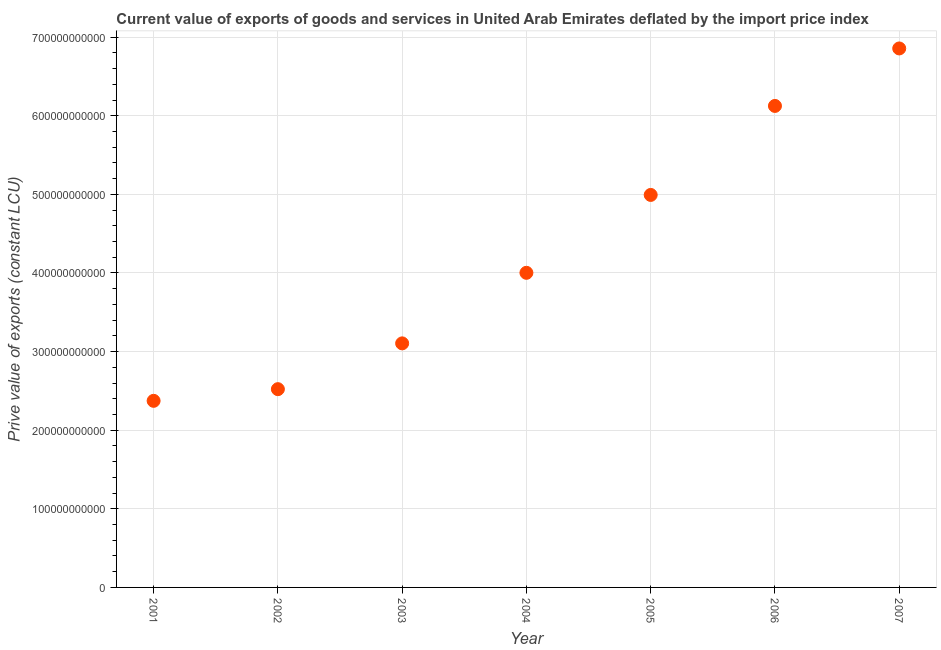What is the price value of exports in 2001?
Give a very brief answer. 2.37e+11. Across all years, what is the maximum price value of exports?
Offer a very short reply. 6.86e+11. Across all years, what is the minimum price value of exports?
Offer a terse response. 2.37e+11. What is the sum of the price value of exports?
Your answer should be compact. 3.00e+12. What is the difference between the price value of exports in 2002 and 2004?
Make the answer very short. -1.48e+11. What is the average price value of exports per year?
Give a very brief answer. 4.28e+11. What is the median price value of exports?
Offer a terse response. 4.00e+11. In how many years, is the price value of exports greater than 620000000000 LCU?
Your response must be concise. 1. Do a majority of the years between 2005 and 2006 (inclusive) have price value of exports greater than 340000000000 LCU?
Your response must be concise. Yes. What is the ratio of the price value of exports in 2004 to that in 2006?
Offer a terse response. 0.65. What is the difference between the highest and the second highest price value of exports?
Provide a succinct answer. 7.31e+1. Is the sum of the price value of exports in 2006 and 2007 greater than the maximum price value of exports across all years?
Offer a very short reply. Yes. What is the difference between the highest and the lowest price value of exports?
Keep it short and to the point. 4.48e+11. Does the price value of exports monotonically increase over the years?
Keep it short and to the point. Yes. How many dotlines are there?
Give a very brief answer. 1. What is the difference between two consecutive major ticks on the Y-axis?
Offer a very short reply. 1.00e+11. What is the title of the graph?
Give a very brief answer. Current value of exports of goods and services in United Arab Emirates deflated by the import price index. What is the label or title of the X-axis?
Give a very brief answer. Year. What is the label or title of the Y-axis?
Offer a terse response. Prive value of exports (constant LCU). What is the Prive value of exports (constant LCU) in 2001?
Make the answer very short. 2.37e+11. What is the Prive value of exports (constant LCU) in 2002?
Your answer should be compact. 2.52e+11. What is the Prive value of exports (constant LCU) in 2003?
Keep it short and to the point. 3.10e+11. What is the Prive value of exports (constant LCU) in 2004?
Your response must be concise. 4.00e+11. What is the Prive value of exports (constant LCU) in 2005?
Keep it short and to the point. 4.99e+11. What is the Prive value of exports (constant LCU) in 2006?
Keep it short and to the point. 6.12e+11. What is the Prive value of exports (constant LCU) in 2007?
Keep it short and to the point. 6.86e+11. What is the difference between the Prive value of exports (constant LCU) in 2001 and 2002?
Make the answer very short. -1.48e+1. What is the difference between the Prive value of exports (constant LCU) in 2001 and 2003?
Ensure brevity in your answer.  -7.31e+1. What is the difference between the Prive value of exports (constant LCU) in 2001 and 2004?
Give a very brief answer. -1.63e+11. What is the difference between the Prive value of exports (constant LCU) in 2001 and 2005?
Your answer should be compact. -2.62e+11. What is the difference between the Prive value of exports (constant LCU) in 2001 and 2006?
Provide a succinct answer. -3.75e+11. What is the difference between the Prive value of exports (constant LCU) in 2001 and 2007?
Offer a terse response. -4.48e+11. What is the difference between the Prive value of exports (constant LCU) in 2002 and 2003?
Make the answer very short. -5.82e+1. What is the difference between the Prive value of exports (constant LCU) in 2002 and 2004?
Your response must be concise. -1.48e+11. What is the difference between the Prive value of exports (constant LCU) in 2002 and 2005?
Your answer should be very brief. -2.47e+11. What is the difference between the Prive value of exports (constant LCU) in 2002 and 2006?
Provide a succinct answer. -3.60e+11. What is the difference between the Prive value of exports (constant LCU) in 2002 and 2007?
Your answer should be compact. -4.33e+11. What is the difference between the Prive value of exports (constant LCU) in 2003 and 2004?
Your answer should be compact. -8.98e+1. What is the difference between the Prive value of exports (constant LCU) in 2003 and 2005?
Offer a very short reply. -1.89e+11. What is the difference between the Prive value of exports (constant LCU) in 2003 and 2006?
Offer a very short reply. -3.02e+11. What is the difference between the Prive value of exports (constant LCU) in 2003 and 2007?
Ensure brevity in your answer.  -3.75e+11. What is the difference between the Prive value of exports (constant LCU) in 2004 and 2005?
Keep it short and to the point. -9.91e+1. What is the difference between the Prive value of exports (constant LCU) in 2004 and 2006?
Offer a very short reply. -2.12e+11. What is the difference between the Prive value of exports (constant LCU) in 2004 and 2007?
Offer a very short reply. -2.85e+11. What is the difference between the Prive value of exports (constant LCU) in 2005 and 2006?
Offer a terse response. -1.13e+11. What is the difference between the Prive value of exports (constant LCU) in 2005 and 2007?
Offer a very short reply. -1.86e+11. What is the difference between the Prive value of exports (constant LCU) in 2006 and 2007?
Ensure brevity in your answer.  -7.31e+1. What is the ratio of the Prive value of exports (constant LCU) in 2001 to that in 2002?
Your answer should be compact. 0.94. What is the ratio of the Prive value of exports (constant LCU) in 2001 to that in 2003?
Offer a terse response. 0.77. What is the ratio of the Prive value of exports (constant LCU) in 2001 to that in 2004?
Provide a short and direct response. 0.59. What is the ratio of the Prive value of exports (constant LCU) in 2001 to that in 2005?
Your answer should be compact. 0.47. What is the ratio of the Prive value of exports (constant LCU) in 2001 to that in 2006?
Your answer should be very brief. 0.39. What is the ratio of the Prive value of exports (constant LCU) in 2001 to that in 2007?
Keep it short and to the point. 0.35. What is the ratio of the Prive value of exports (constant LCU) in 2002 to that in 2003?
Your response must be concise. 0.81. What is the ratio of the Prive value of exports (constant LCU) in 2002 to that in 2004?
Your answer should be very brief. 0.63. What is the ratio of the Prive value of exports (constant LCU) in 2002 to that in 2005?
Make the answer very short. 0.51. What is the ratio of the Prive value of exports (constant LCU) in 2002 to that in 2006?
Offer a very short reply. 0.41. What is the ratio of the Prive value of exports (constant LCU) in 2002 to that in 2007?
Your response must be concise. 0.37. What is the ratio of the Prive value of exports (constant LCU) in 2003 to that in 2004?
Your answer should be compact. 0.78. What is the ratio of the Prive value of exports (constant LCU) in 2003 to that in 2005?
Ensure brevity in your answer.  0.62. What is the ratio of the Prive value of exports (constant LCU) in 2003 to that in 2006?
Make the answer very short. 0.51. What is the ratio of the Prive value of exports (constant LCU) in 2003 to that in 2007?
Provide a succinct answer. 0.45. What is the ratio of the Prive value of exports (constant LCU) in 2004 to that in 2005?
Keep it short and to the point. 0.8. What is the ratio of the Prive value of exports (constant LCU) in 2004 to that in 2006?
Your answer should be very brief. 0.65. What is the ratio of the Prive value of exports (constant LCU) in 2004 to that in 2007?
Make the answer very short. 0.58. What is the ratio of the Prive value of exports (constant LCU) in 2005 to that in 2006?
Offer a very short reply. 0.81. What is the ratio of the Prive value of exports (constant LCU) in 2005 to that in 2007?
Your answer should be compact. 0.73. What is the ratio of the Prive value of exports (constant LCU) in 2006 to that in 2007?
Provide a succinct answer. 0.89. 